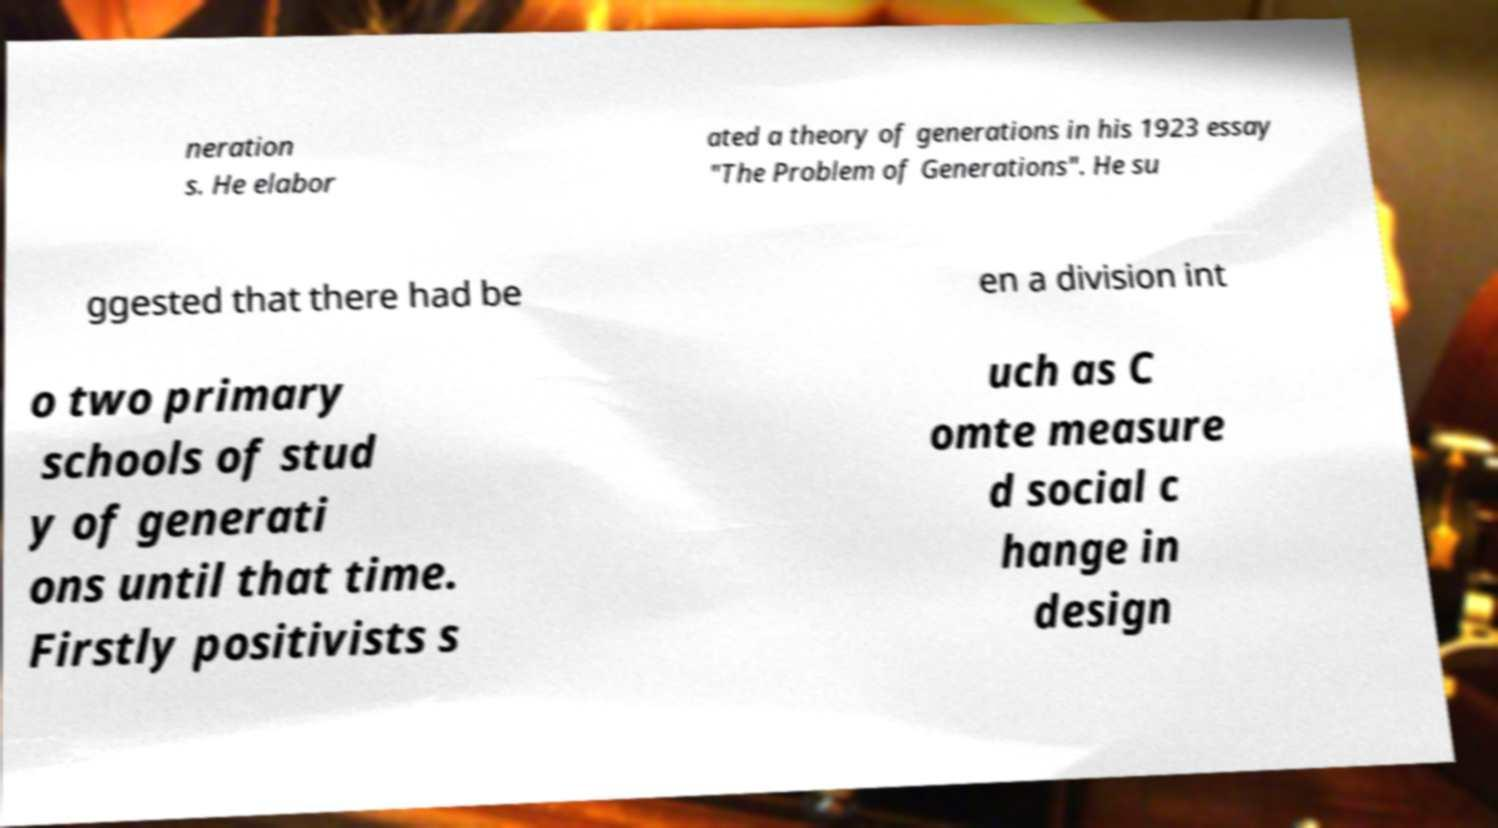Can you accurately transcribe the text from the provided image for me? neration s. He elabor ated a theory of generations in his 1923 essay "The Problem of Generations". He su ggested that there had be en a division int o two primary schools of stud y of generati ons until that time. Firstly positivists s uch as C omte measure d social c hange in design 